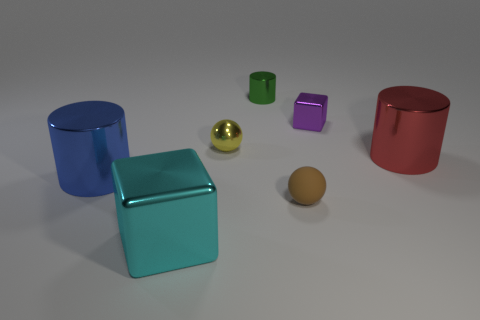Add 3 big matte things. How many objects exist? 10 Subtract all cylinders. How many objects are left? 4 Subtract all small blocks. Subtract all small green objects. How many objects are left? 5 Add 2 tiny metallic objects. How many tiny metallic objects are left? 5 Add 5 tiny purple metal spheres. How many tiny purple metal spheres exist? 5 Subtract 0 gray balls. How many objects are left? 7 